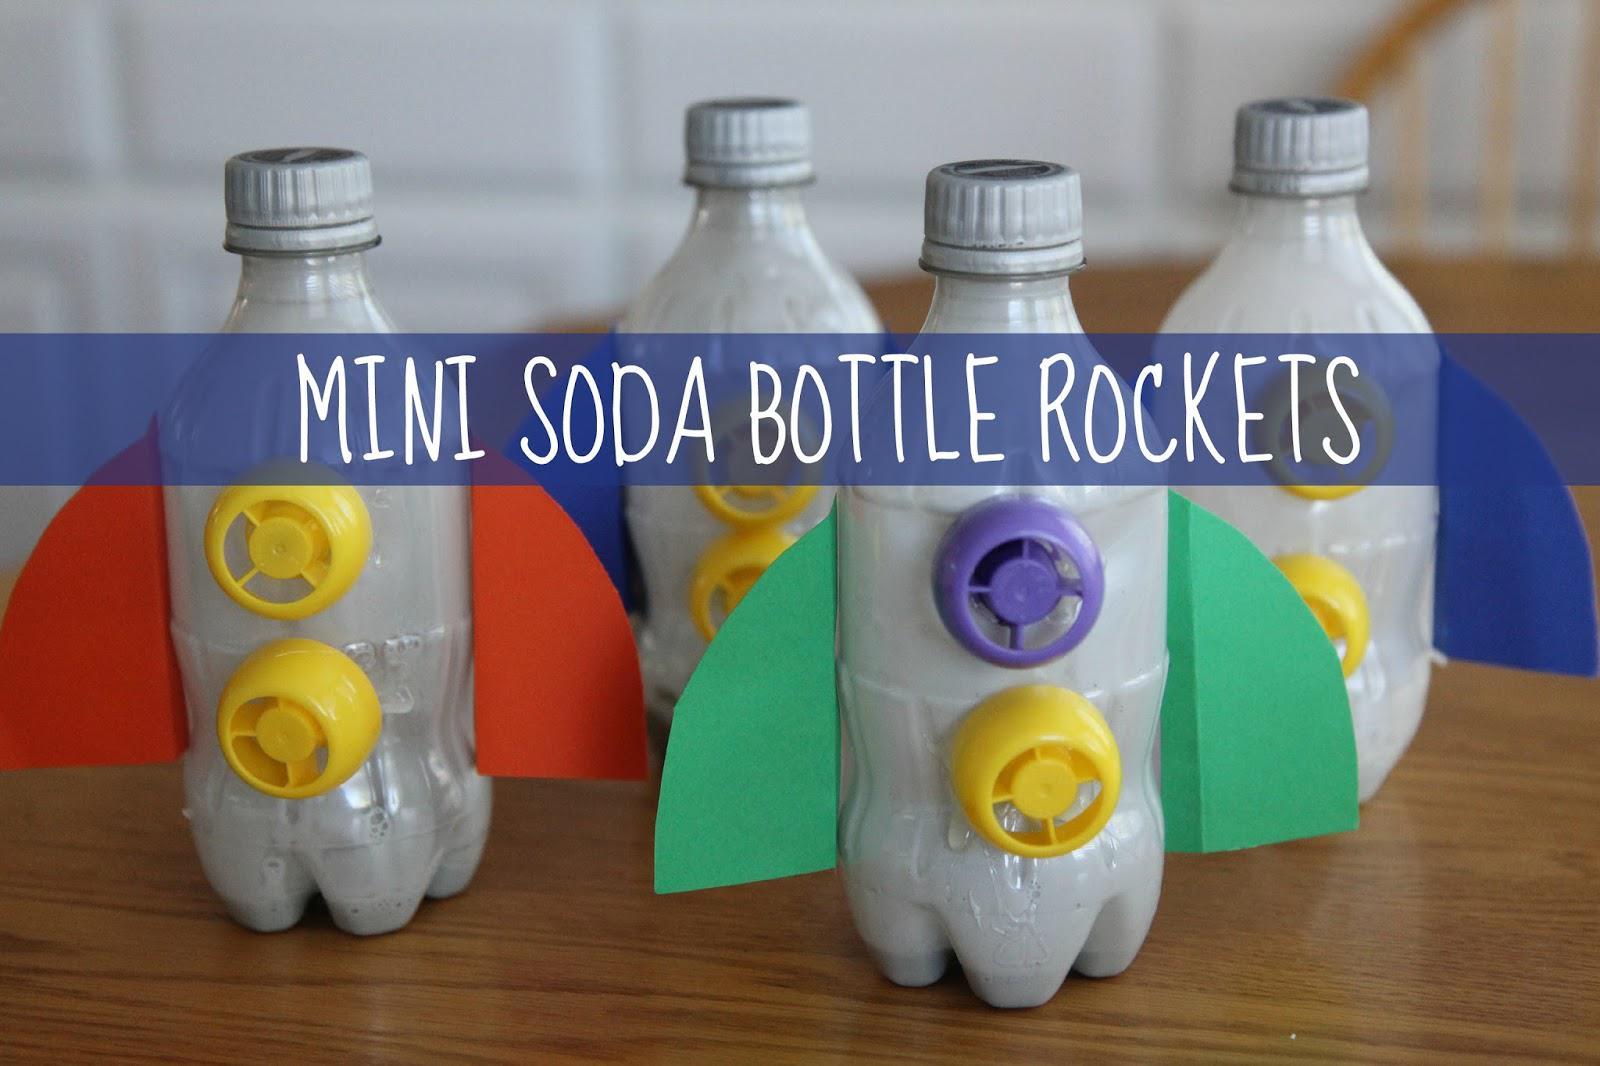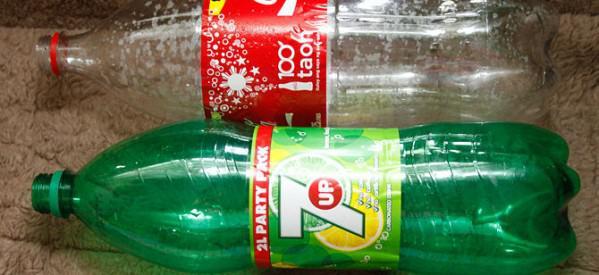The first image is the image on the left, the second image is the image on the right. Considering the images on both sides, is "A person is holding the bottle rocket in one of the images." valid? Answer yes or no. No. The first image is the image on the left, the second image is the image on the right. Considering the images on both sides, is "The left image features one inverted bottle with fins on its base to create a rocket ship." valid? Answer yes or no. No. 